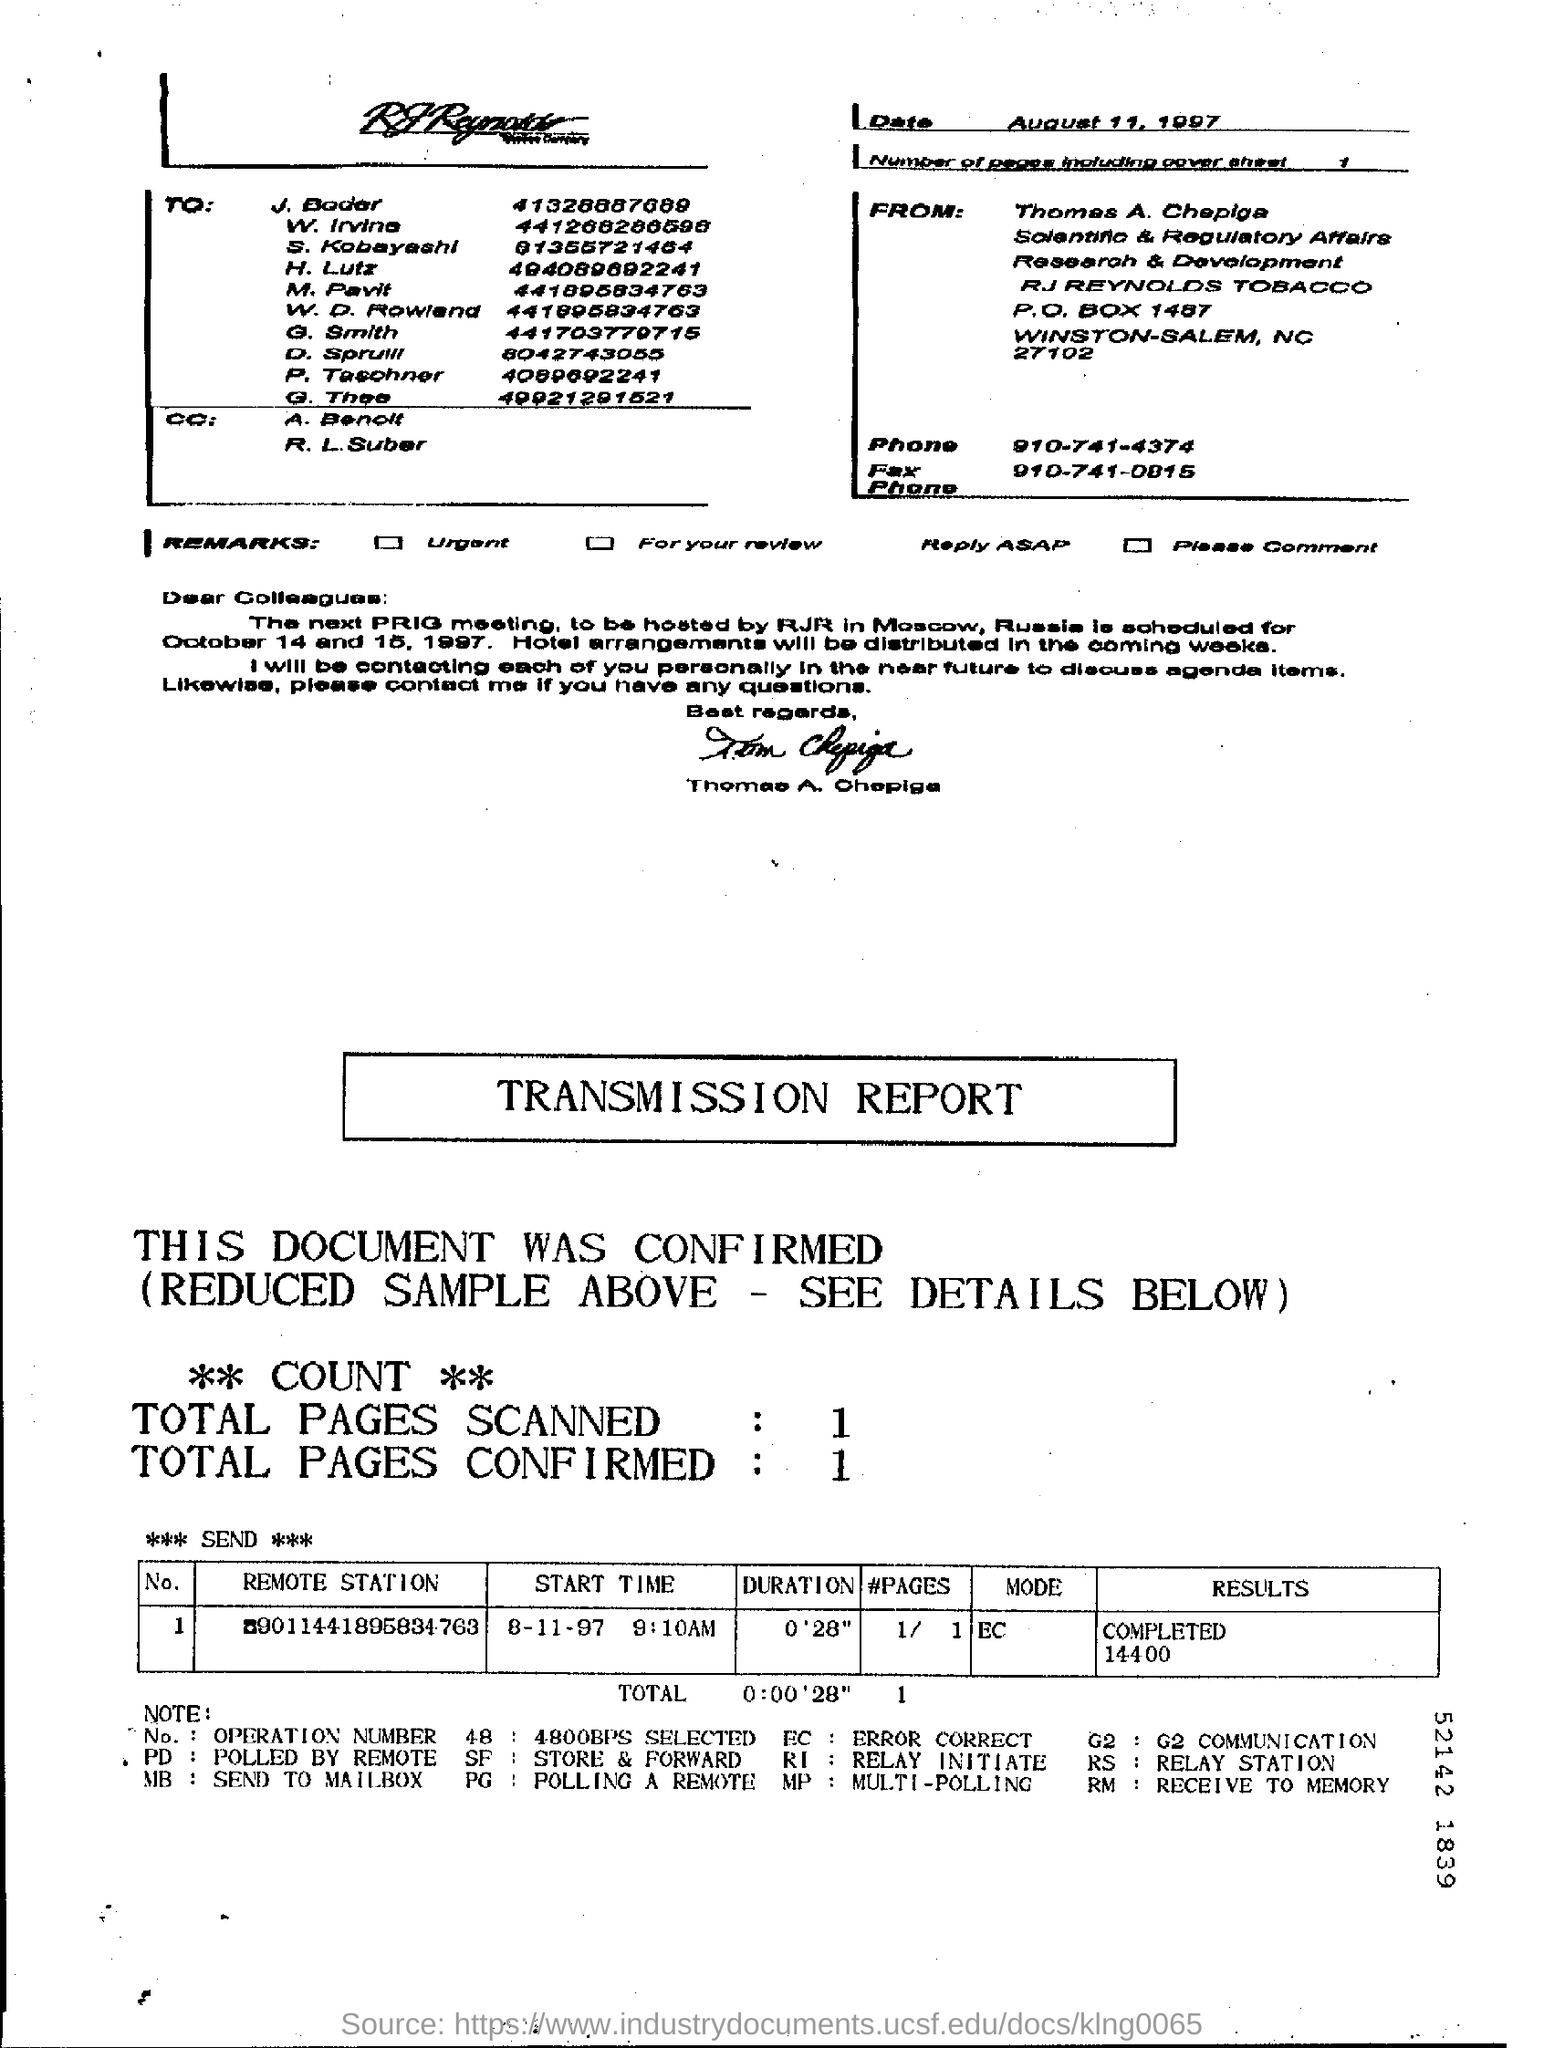Draw attention to some important aspects in this diagram. The phone number provided on the page is 910-741-4374. The report indicates that a total of 1 page was scanned. The report confirms a total of 1 page. There are one page including the cover sheet. The fax number mentioned in the given letter is 910-741-0815. 